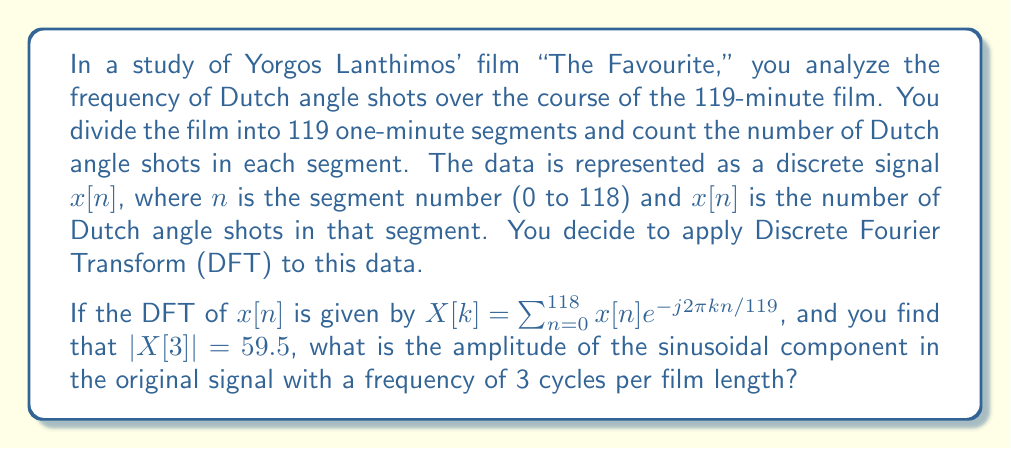Can you solve this math problem? To solve this problem, we need to understand the relationship between the DFT and the original signal's sinusoidal components. Let's break it down step by step:

1) The DFT $X[k]$ represents the frequency content of the signal. $|X[k]|$ is the magnitude of the $k$-th frequency component.

2) In this case, we're given $|X[3]| = 59.5$. This corresponds to the frequency component that completes 3 cycles over the entire signal length (119 minutes).

3) For real-valued signals (which our count of Dutch angle shots certainly is), the DFT has conjugate symmetry. This means that the magnitude of $X[k]$ and $X[N-k]$ are the same, where N is the total number of samples (119 in this case).

4) The relationship between the DFT magnitude and the amplitude of the corresponding sinusoidal component in the time domain is:

   $$A = \frac{2|X[k]|}{N}$$

   Where $A$ is the amplitude of the sinusoidal component and $N$ is the total number of samples.

5) In our case:
   $|X[3]| = 59.5$
   $N = 119$

6) Plugging these values into the formula:

   $$A = \frac{2 * 59.5}{119} = \frac{119}{119} = 1$$

Therefore, the amplitude of the sinusoidal component with frequency 3 cycles per film length is 1.
Answer: 1 